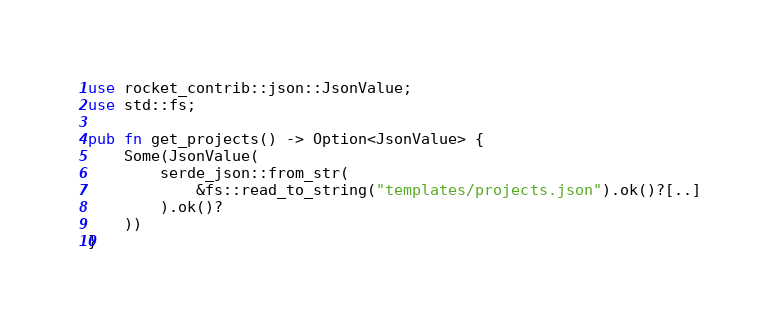<code> <loc_0><loc_0><loc_500><loc_500><_Rust_>use rocket_contrib::json::JsonValue;
use std::fs;

pub fn get_projects() -> Option<JsonValue> {
    Some(JsonValue(
        serde_json::from_str(
            &fs::read_to_string("templates/projects.json").ok()?[..]
        ).ok()?
    ))            
}
</code> 